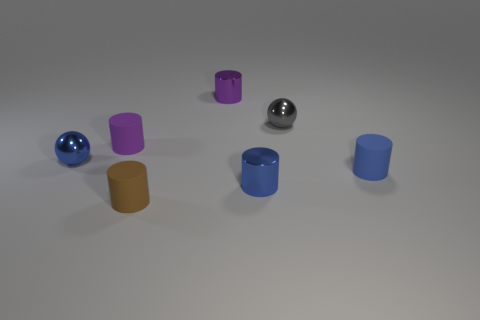Subtract all brown matte cylinders. How many cylinders are left? 4 Subtract 2 cylinders. How many cylinders are left? 3 Subtract all brown cylinders. How many cylinders are left? 4 Subtract all red cylinders. Subtract all purple blocks. How many cylinders are left? 5 Add 1 brown matte objects. How many objects exist? 8 Subtract all cylinders. How many objects are left? 2 Subtract 1 blue spheres. How many objects are left? 6 Subtract all purple shiny cylinders. Subtract all metal cylinders. How many objects are left? 4 Add 1 small blue metallic spheres. How many small blue metallic spheres are left? 2 Add 3 metallic cylinders. How many metallic cylinders exist? 5 